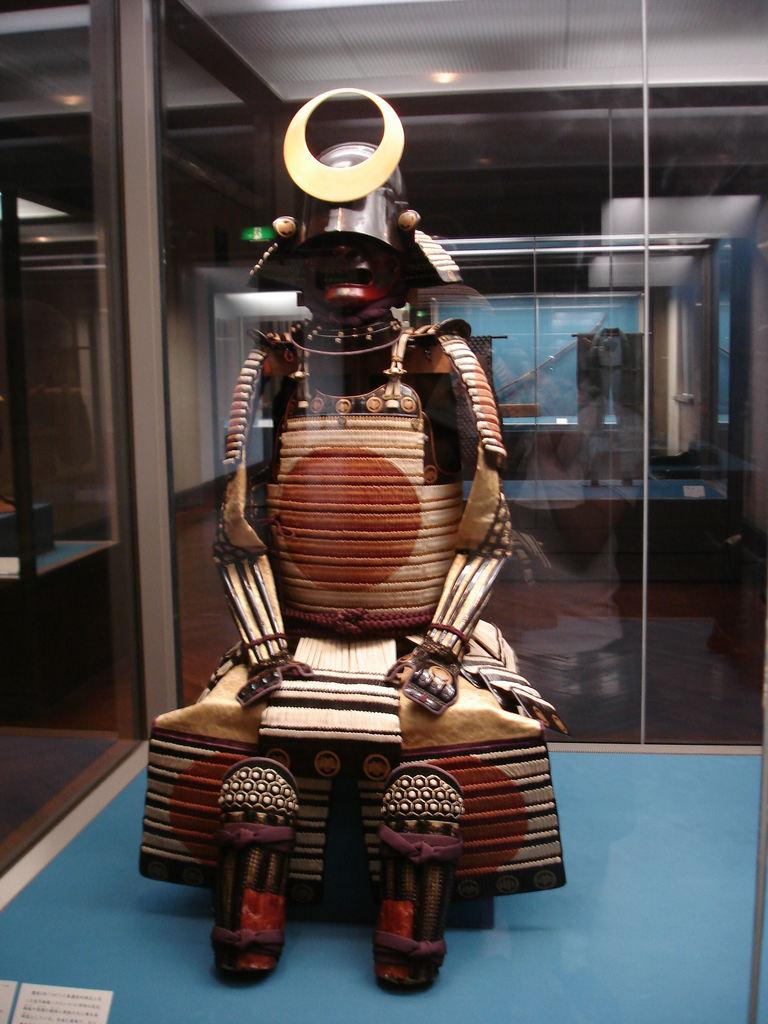What is inside the glass in the image? There is a statue inside the glass in the image. Are there any other objects or statues inside the glass? Yes, there are additional statues inside the glass in the image. Where is the toothbrush located in the image? There is no toothbrush present in the image. What type of chair is visible in the image? There is no chair present in the image. 